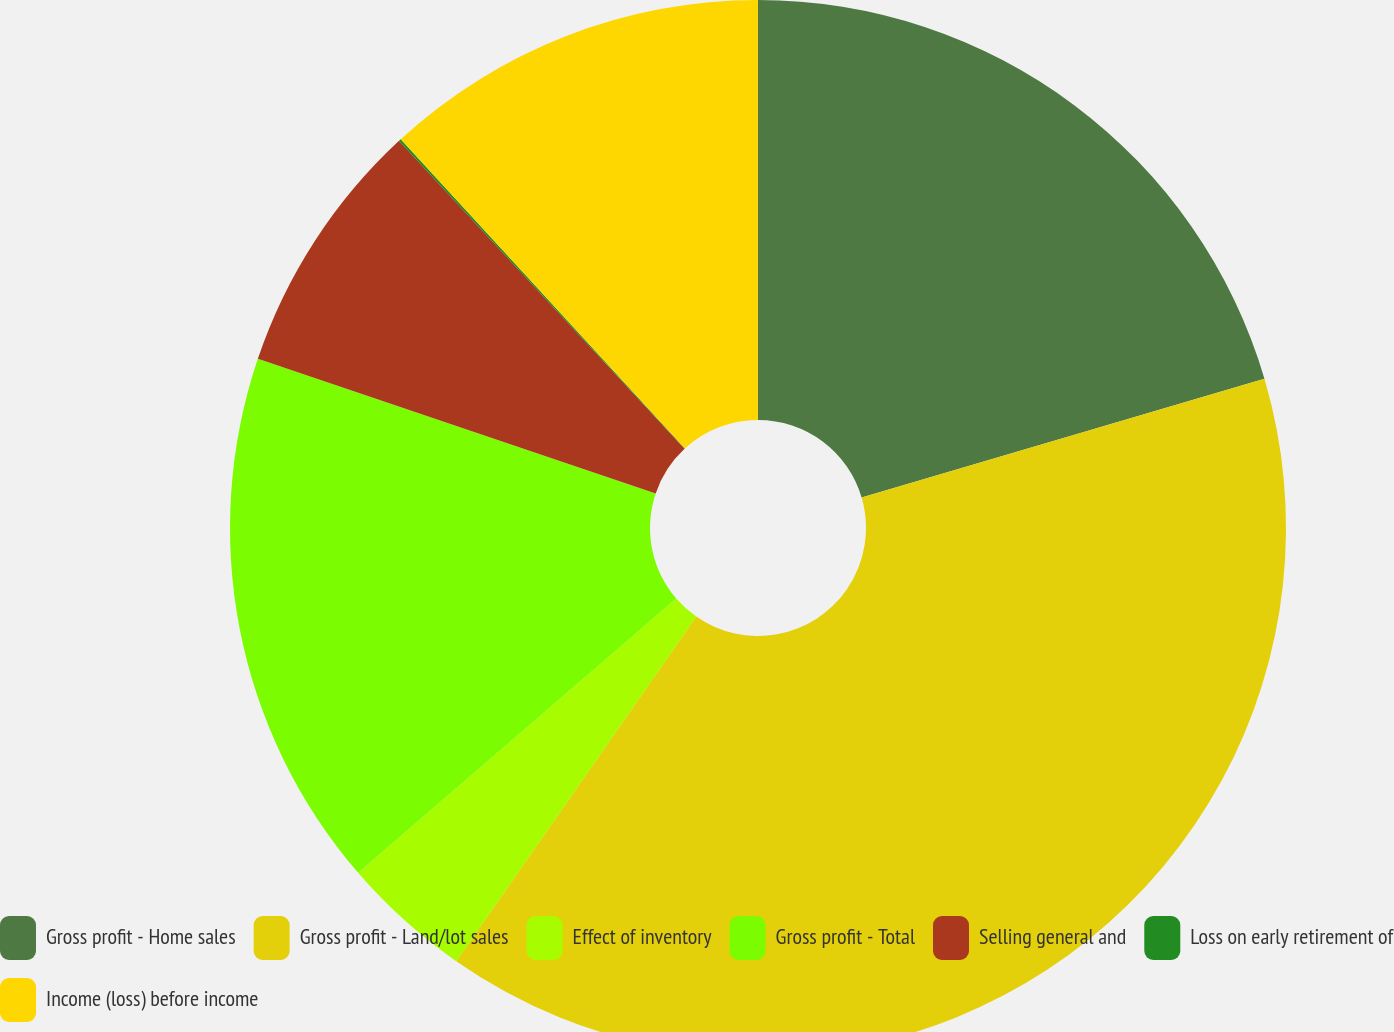Convert chart. <chart><loc_0><loc_0><loc_500><loc_500><pie_chart><fcel>Gross profit - Home sales<fcel>Gross profit - Land/lot sales<fcel>Effect of inventory<fcel>Gross profit - Total<fcel>Selling general and<fcel>Loss on early retirement of<fcel>Income (loss) before income<nl><fcel>20.44%<fcel>39.25%<fcel>3.99%<fcel>16.52%<fcel>7.91%<fcel>0.07%<fcel>11.83%<nl></chart> 